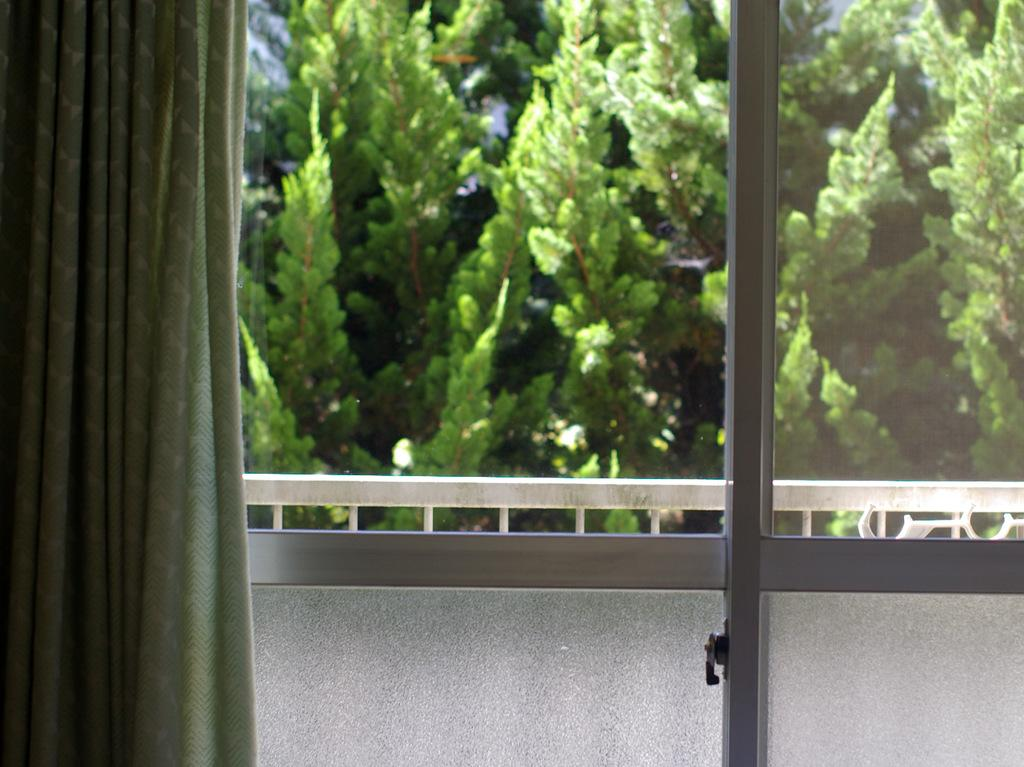What type of covering can be seen in the image? There is a curtain in the image. What architectural feature is present in the image? There is a window in the image. What can be seen through the window? Railing and leaves are visible through the window. Can you hear the powder being sprinkled in the image? There is no mention of powder or any sound in the image, so it cannot be heard. Is there a spy visible in the image? There is no indication of a spy or any person in the image. 